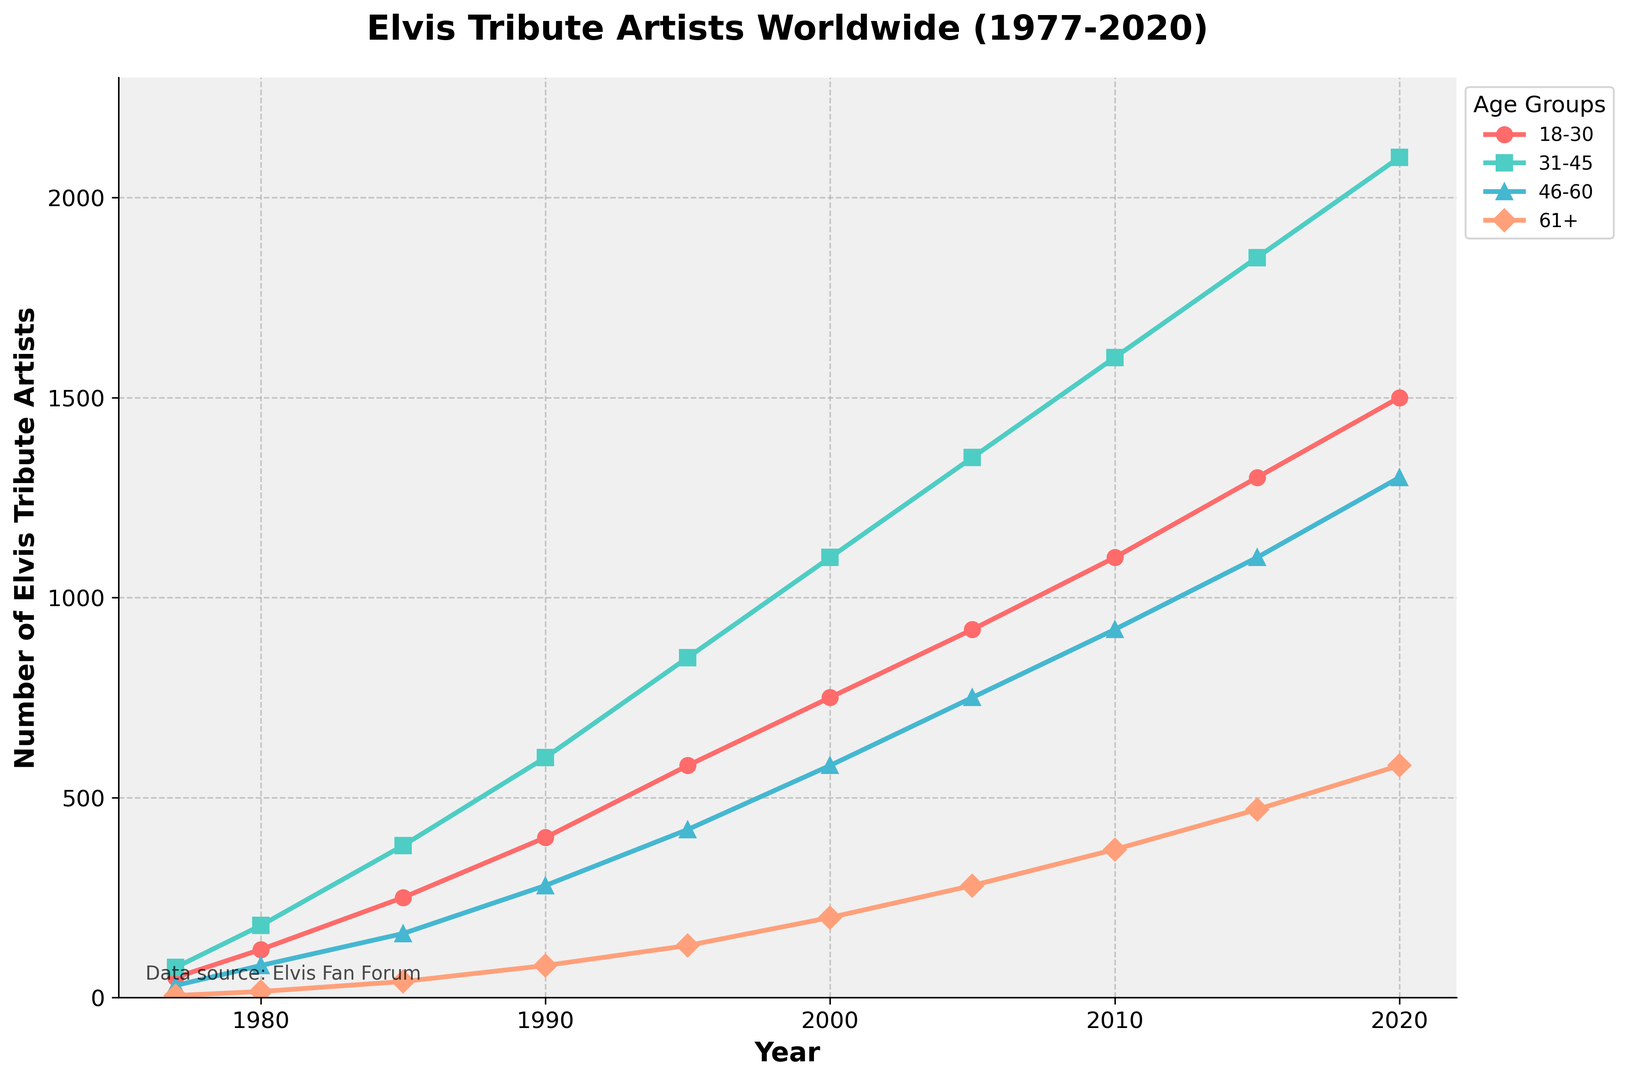What is the total number of Elvis tribute artists registered in 2020? To find the total number, add the values for all age groups in 2020. This would be 1500 (18-30) + 2100 (31-45) + 1300 (46-60) + 580 (61+).
Answer: 5480 Which age group saw the largest increase in the number of Elvis tribute artists between 1977 and 2020? Calculate the difference for each age group between 2020 and 1977. For 18-30: 1500 - 50 = 1450. For 31-45: 2100 - 75 = 2025. For 46-60: 1300 - 30 = 1270. For 61+: 580 - 5 = 575. The 31-45 age group saw the largest increase.
Answer: 31-45 What was the total number of Elvis tribute artists in 1995 across all age groups? Add the values for all age groups in 1995: 580 (18-30) + 850 (31-45) + 420 (46-60) + 130 (61+).
Answer: 1980 By how much did the number of Elvis tribute artists in the 31-45 age group increase from 1980 to 1990? Subtract the 1980 value for 31-45 from the 1990 value: 600 - 180.
Answer: 420 Which age group had the lowest number of Elvis tribute artists in 1977? Compare the values for all age groups in 1977: 18-30 (50), 31-45 (75), 46-60 (30), 61+ (5). The lowest number is in the 61+ group.
Answer: 61+ How does the trend of the 18-30 age group compare visually to the 46-60 age group from 1977 to 2020? Visually, both groups show an upward trend. However, the 18-30 age group shows a more dramatic increase and stays consistently higher than the 46-60 age group throughout the period.
Answer: 18-30 > 46-60 Between which years did the number of Elvis tribute artists in the 61+ age group first cross the 100 mark? Check the values for the 61+ age group over the years: It crossed 100 between 1990 (80) and 1995 (130).
Answer: 1990 and 1995 In which year did the 31-45 age group reach 1600 tribute artists? Check the values over the years for the 31-45 age group. In 2010, the number reaches 1600.
Answer: 2010 